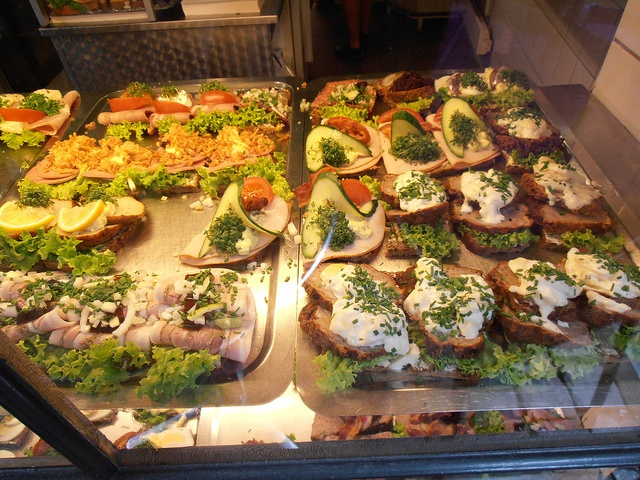Describe the objects in this image and their specific colors. I can see sandwich in black, olive, maroon, and tan tones, sandwich in black, gray, maroon, and olive tones, sandwich in black, tan, olive, and brown tones, sandwich in black, olive, tan, maroon, and brown tones, and sandwich in black, tan, khaki, olive, and brown tones in this image. 